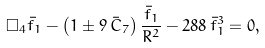<formula> <loc_0><loc_0><loc_500><loc_500>\Box _ { 4 } \bar { f } _ { 1 } - \left ( 1 \pm 9 \, \bar { C } _ { 7 } \right ) \frac { \bar { f } _ { 1 } } { R ^ { 2 } } - 2 8 8 \, \bar { f } _ { 1 } ^ { 3 } = 0 ,</formula> 